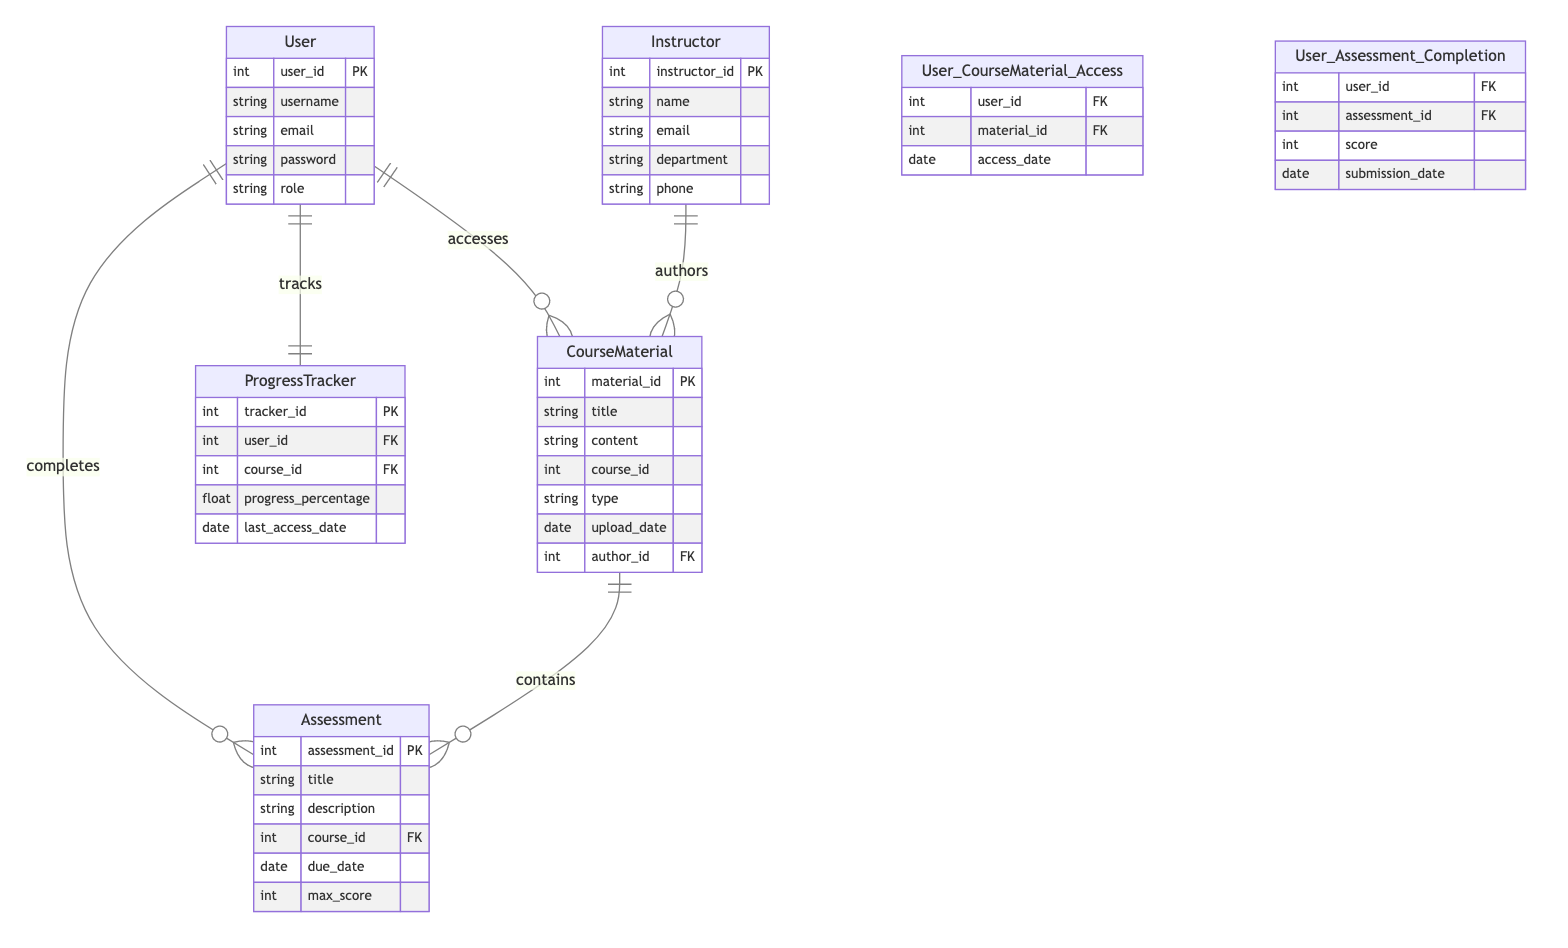What is the primary key of the User entity? The primary key of the User entity is "user_id". This is indicated in the diagram where the user entity is defined, showing "user_id" as the unique identifier for this entity.
Answer: user_id How many attributes does the Assessment entity have? The Assessment entity has five attributes: title, description, course_id, due_date, and max_score. These attributes are listed directly under the Assessment entity in the diagram.
Answer: five Which relationship indicates how users complete assessments? The relationship that indicates how users complete assessments is "User_Assessment_Completion". This is directly labeled in the diagram, showing the connection between the User and Assessment entities.
Answer: User_Assessment_Completion What type of relationship exists between CourseMaterial and Assessment? The relationship between CourseMaterial and Assessment is "one-to-many", as shown in the diagram where one CourseMaterial can contain multiple Assessments.
Answer: one-to-many How many entities are present in the diagram? There are five entities in the diagram: User, CourseMaterial, Assessment, Instructor, and ProgressTracker. Each entity is clearly delineated in the diagram, and counted gives us five.
Answer: five Which entity tracks user progress in a course? The entity that tracks user progress in a course is "ProgressTracker". This is clearly labeled in the diagram, indicating its function related to users and courses.
Answer: ProgressTracker What is the cardinality type of the relationship between User and ProgressTracker? The cardinality type of the relationship between User and ProgressTracker is "one-to-one". This is specified in the diagram where it shows that each user has one progress tracker.
Answer: one-to-one What attribute links ProgressTracker to the User entity? The attribute that links ProgressTracker to the User entity is "user_id". This foreign key in ProgressTracker connects back to the primary key in User.
Answer: user_id How many relationships are there in total in this diagram? There are six relationships in total in the diagram: User_CourseMaterial_Access, User_Assessment_Completion, Instructor_CourseMaterial_Authorship, User_ProgressTracker, and Course_Assessment_Assignment. Counting them gives us six.
Answer: six 